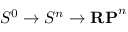Convert formula to latex. <formula><loc_0><loc_0><loc_500><loc_500>S ^ { 0 } \to S ^ { n } \to R P ^ { n }</formula> 